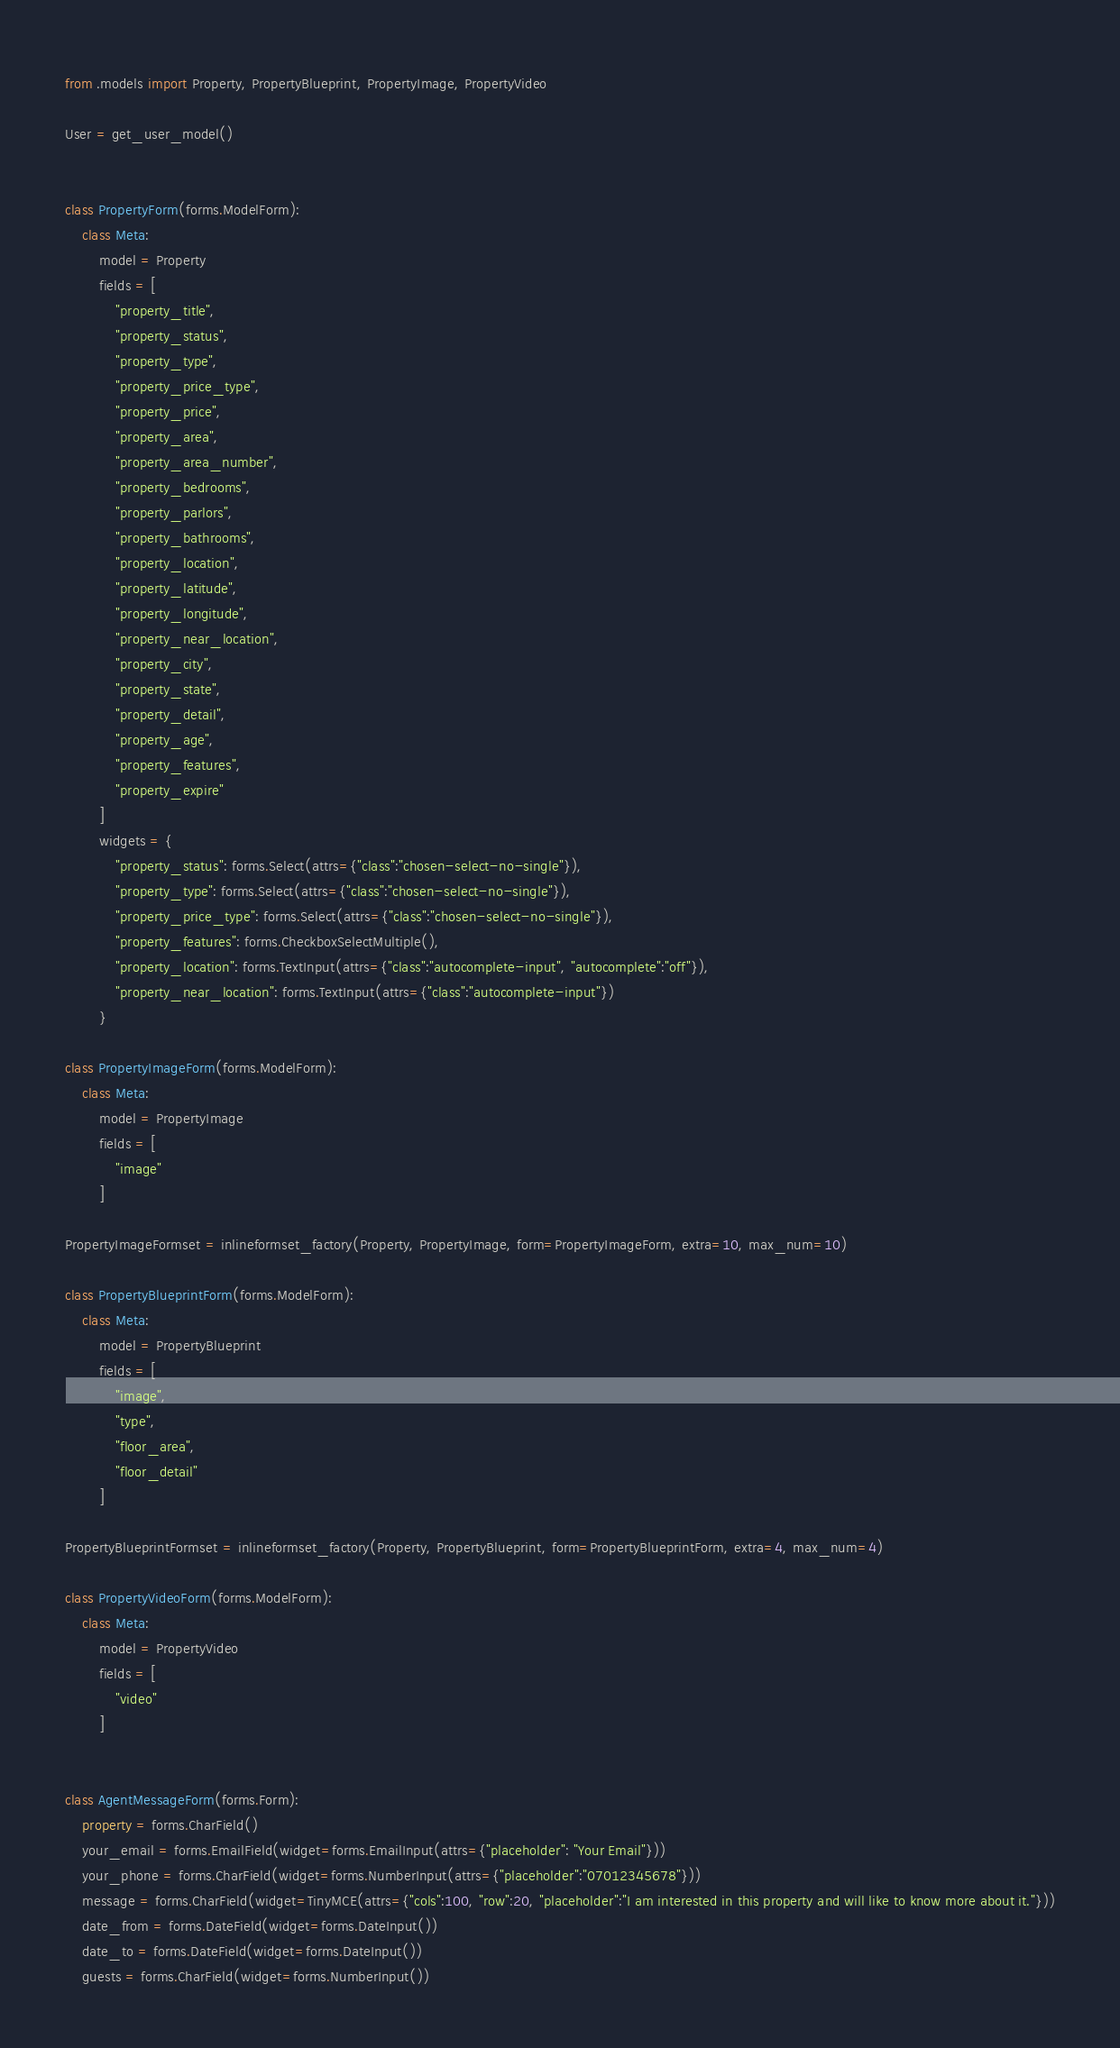<code> <loc_0><loc_0><loc_500><loc_500><_Python_>from .models import Property, PropertyBlueprint, PropertyImage, PropertyVideo

User = get_user_model()
    

class PropertyForm(forms.ModelForm):
    class Meta:
        model = Property
        fields = [
            "property_title",
            "property_status",
            "property_type",
            "property_price_type",
            "property_price",
            "property_area",
            "property_area_number",
            "property_bedrooms",
            "property_parlors",
            "property_bathrooms",
            "property_location",
            "property_latitude",
            "property_longitude",
            "property_near_location",
            "property_city",
            "property_state",
            "property_detail",
            "property_age",
            "property_features",
            "property_expire"
        ]
        widgets = {
            "property_status": forms.Select(attrs={"class":"chosen-select-no-single"}),
            "property_type": forms.Select(attrs={"class":"chosen-select-no-single"}),
            "property_price_type": forms.Select(attrs={"class":"chosen-select-no-single"}),
            "property_features": forms.CheckboxSelectMultiple(),
            "property_location": forms.TextInput(attrs={"class":"autocomplete-input", "autocomplete":"off"}),
            "property_near_location": forms.TextInput(attrs={"class":"autocomplete-input"})
        }

class PropertyImageForm(forms.ModelForm):
    class Meta:
        model = PropertyImage
        fields = [
            "image"
        ]

PropertyImageFormset = inlineformset_factory(Property, PropertyImage, form=PropertyImageForm, extra=10, max_num=10)

class PropertyBlueprintForm(forms.ModelForm):
    class Meta:
        model = PropertyBlueprint
        fields = [
            "image",
            "type",
            "floor_area",
            "floor_detail"
        ]

PropertyBlueprintFormset = inlineformset_factory(Property, PropertyBlueprint, form=PropertyBlueprintForm, extra=4, max_num=4)

class PropertyVideoForm(forms.ModelForm):
    class Meta:
        model = PropertyVideo
        fields = [
            "video"
        ]


class AgentMessageForm(forms.Form):
    property = forms.CharField()
    your_email = forms.EmailField(widget=forms.EmailInput(attrs={"placeholder": "Your Email"}))
    your_phone = forms.CharField(widget=forms.NumberInput(attrs={"placeholder":"07012345678"}))
    message = forms.CharField(widget=TinyMCE(attrs={"cols":100, "row":20, "placeholder":"I am interested in this property and will like to know more about it."}))
    date_from = forms.DateField(widget=forms.DateInput())
    date_to = forms.DateField(widget=forms.DateInput())
    guests = forms.CharField(widget=forms.NumberInput())
</code> 